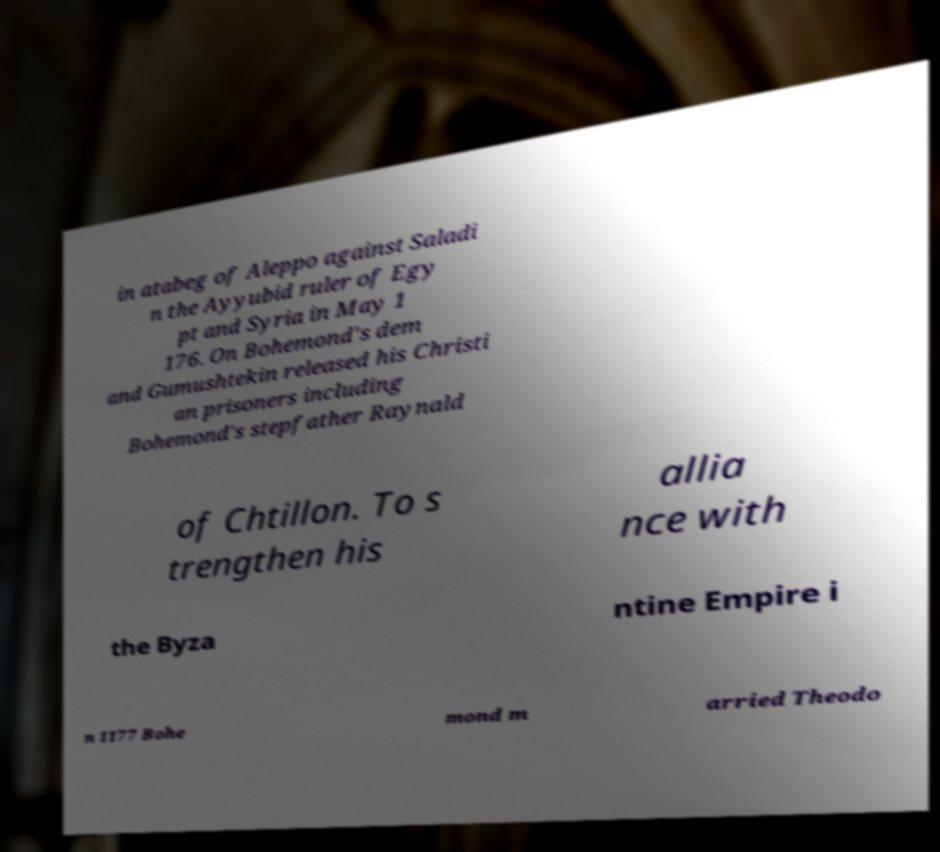Could you assist in decoding the text presented in this image and type it out clearly? in atabeg of Aleppo against Saladi n the Ayyubid ruler of Egy pt and Syria in May 1 176. On Bohemond's dem and Gumushtekin released his Christi an prisoners including Bohemond's stepfather Raynald of Chtillon. To s trengthen his allia nce with the Byza ntine Empire i n 1177 Bohe mond m arried Theodo 